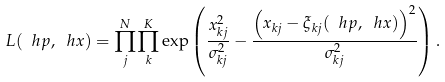<formula> <loc_0><loc_0><loc_500><loc_500>L ( \ h p , \ h x ) = \prod _ { j } ^ { N } \prod _ { k } ^ { K } \exp \left ( \frac { x _ { k j } ^ { 2 } } { \sigma _ { k j } ^ { 2 } } - \frac { \left ( x _ { k j } - \xi _ { k j } ( \ h p , \ h x ) \right ) ^ { 2 } } { \sigma _ { k j } ^ { 2 } } \right ) .</formula> 